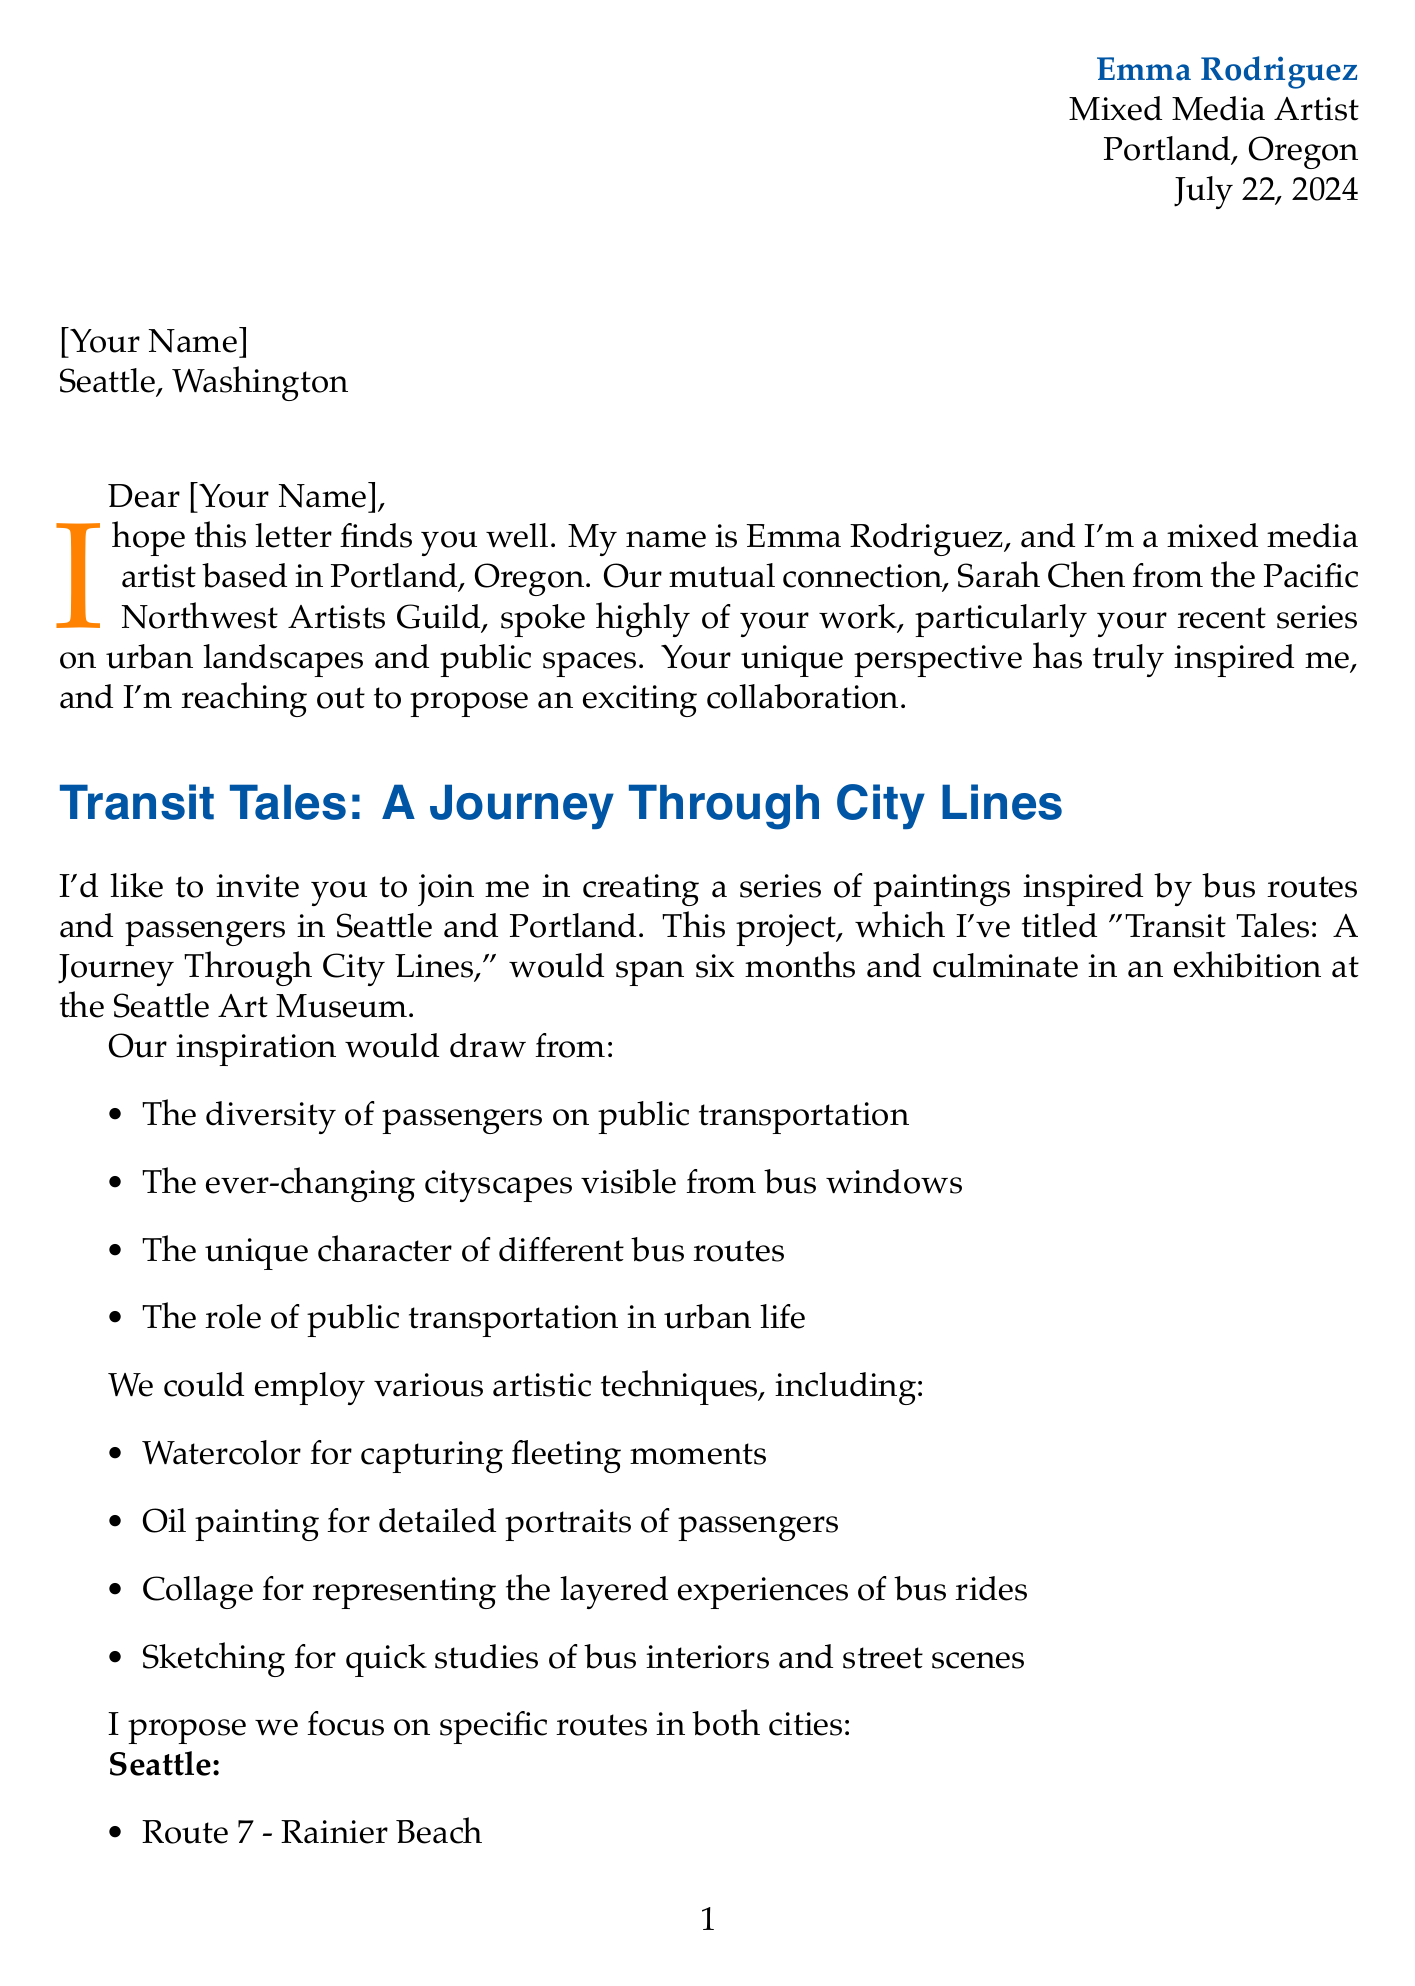What is the sender's name? The sender of the letter is Emma Rodriguez, as stated at the beginning of the document.
Answer: Emma Rodriguez What city is the sender based in? The document specifies that Emma Rodriguez is based in Portland, Oregon.
Answer: Portland, Oregon What is the project title proposed by Emma? The project title mentioned in the letter is "Transit Tales: A Journey Through City Lines."
Answer: Transit Tales: A Journey Through City Lines How long is the proposed collaboration intended to last? The duration of the project is specified as six months in the letter.
Answer: 6 months Which exhibition venue is mentioned for the culmination of the project? The letter indicates that the exhibition will take place at the Seattle Art Museum.
Answer: Seattle Art Museum What technique is suggested for capturing fleeting moments? The letter suggests using watercolor as a technique for capturing fleeting moments.
Answer: Watercolor Name one specific bus route mentioned for Seattle. The letter lists several routes, including Route 7 - Rainier Beach as a specific bus route in Seattle.
Answer: Route 7 - Rainier Beach What are the potential themes listed for the project? The document outlines several themes, including community connections and urban solitude.
Answer: Community connections What is one of the collaboration benefits mentioned? One benefit noted in the letter is the increased visibility for both artists involved in the collaboration.
Answer: Increased visibility for both artists What next step includes visiting each other's cities? The letter outlines that visiting each other's cities for on-site inspiration is one of the next steps in the collaboration.
Answer: Visit each other's cities 